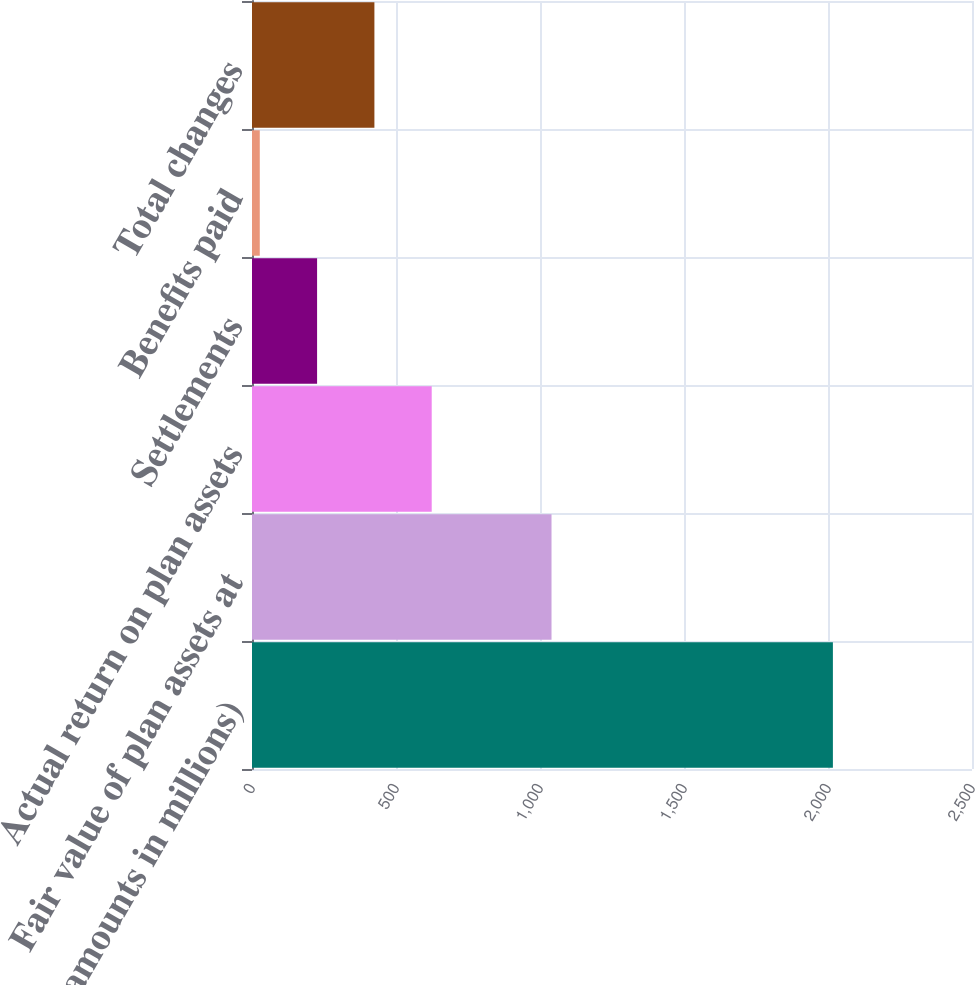<chart> <loc_0><loc_0><loc_500><loc_500><bar_chart><fcel>(dollar amounts in millions)<fcel>Fair value of plan assets at<fcel>Actual return on plan assets<fcel>Settlements<fcel>Benefits paid<fcel>Total changes<nl><fcel>2017<fcel>1040<fcel>624<fcel>226<fcel>27<fcel>425<nl></chart> 